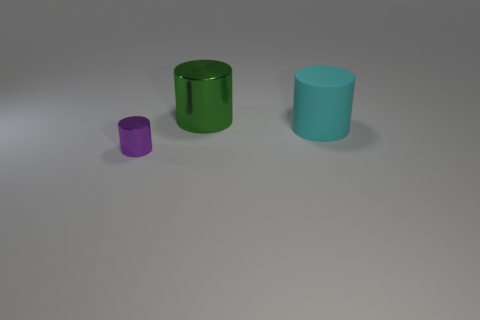Add 1 cyan matte spheres. How many objects exist? 4 Subtract all large purple matte blocks. Subtract all small shiny cylinders. How many objects are left? 2 Add 3 large green cylinders. How many large green cylinders are left? 4 Add 3 cyan matte things. How many cyan matte things exist? 4 Subtract 1 green cylinders. How many objects are left? 2 